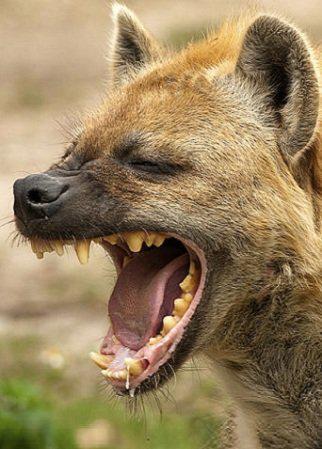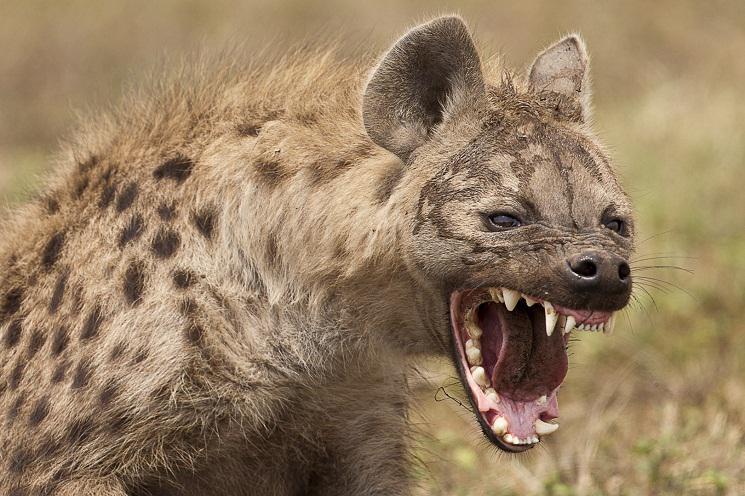The first image is the image on the left, the second image is the image on the right. Examine the images to the left and right. Is the description "Only one animal has its mouth open wide showing its teeth and tongue." accurate? Answer yes or no. No. 